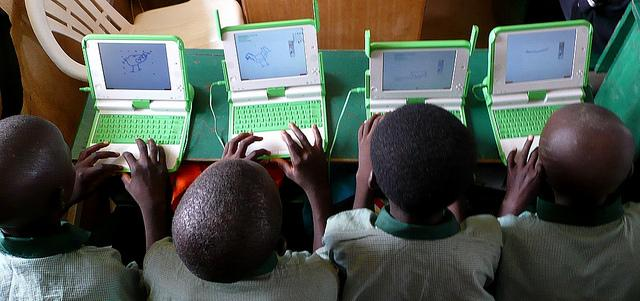Why are all the boys dressed alike? Please explain your reasoning. dress code. Most places of learning abroad have strict codes as to what they can wear. 